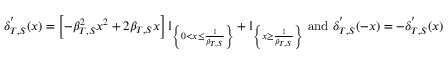<formula> <loc_0><loc_0><loc_500><loc_500>\delta _ { T , S } ^ { ^ { \prime } } ( x ) = \left [ - \beta _ { T , S } ^ { 2 } x ^ { 2 } + 2 \beta _ { T , S } x \right ] \mathbb { I } _ { \left \{ 0 < x \leq \frac { 1 } { \beta _ { T , S } } \right \} } + \mathbb { I } _ { \left \{ x \geq \frac { 1 } { \beta _ { T , S } } \right \} } a n d \delta _ { T , S } ^ { ^ { \prime } } ( - x ) = - \delta _ { T , S } ^ { ^ { \prime } } ( x )</formula> 